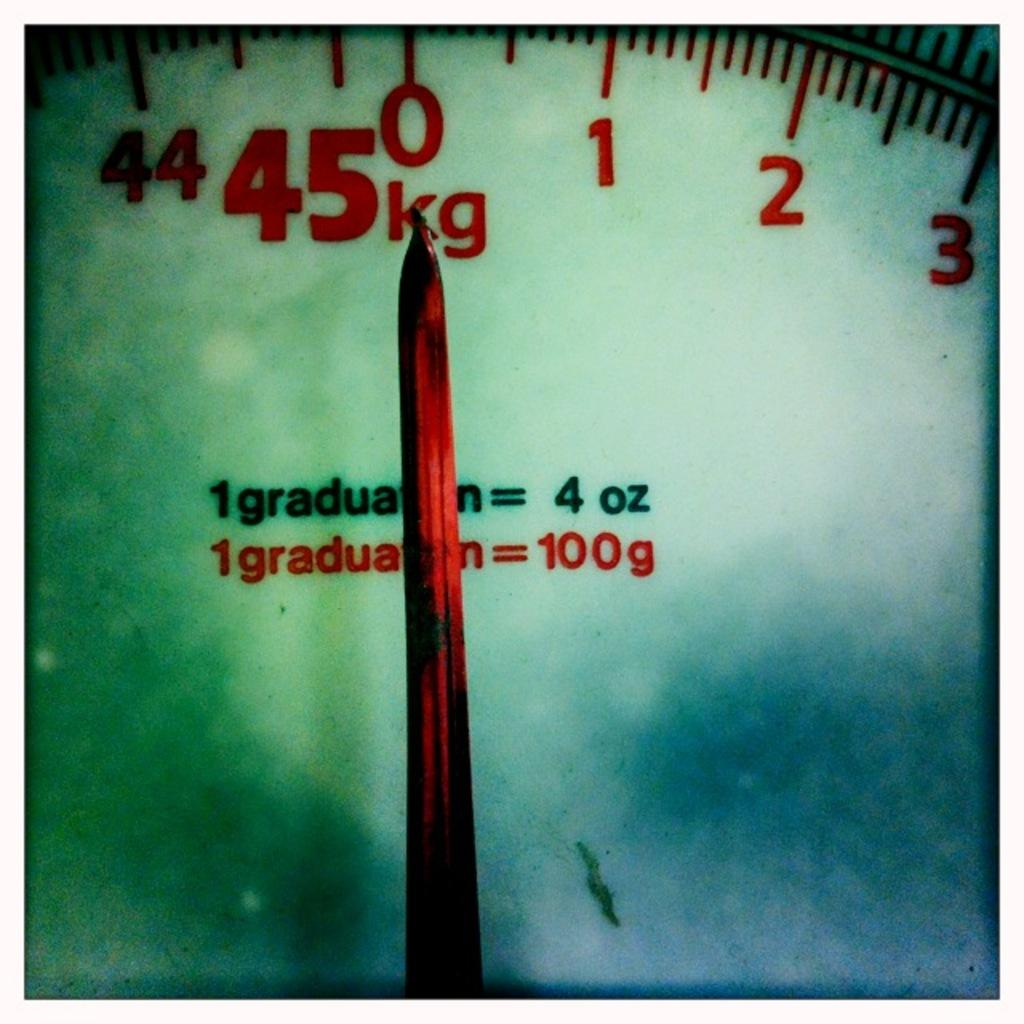<image>
Present a compact description of the photo's key features. Measuring object that measure graduation, kg, and ounces. 